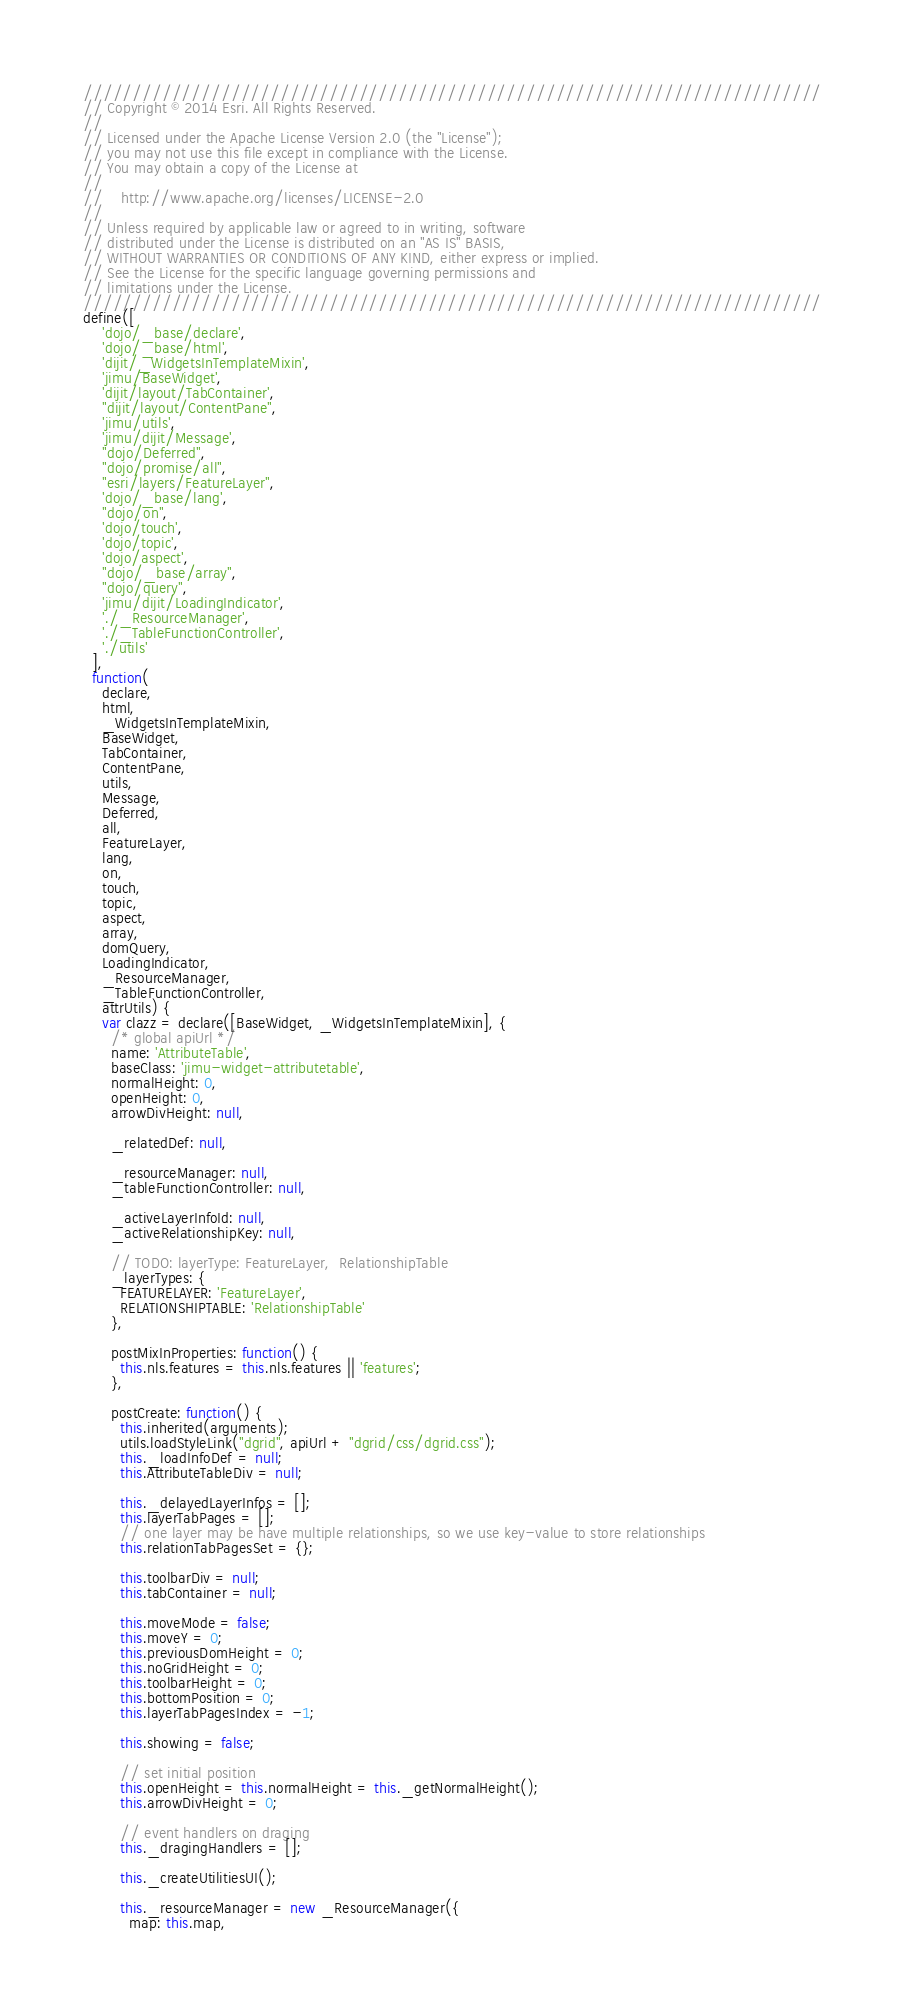<code> <loc_0><loc_0><loc_500><loc_500><_JavaScript_>///////////////////////////////////////////////////////////////////////////
// Copyright © 2014 Esri. All Rights Reserved.
//
// Licensed under the Apache License Version 2.0 (the "License");
// you may not use this file except in compliance with the License.
// You may obtain a copy of the License at
//
//    http://www.apache.org/licenses/LICENSE-2.0
//
// Unless required by applicable law or agreed to in writing, software
// distributed under the License is distributed on an "AS IS" BASIS,
// WITHOUT WARRANTIES OR CONDITIONS OF ANY KIND, either express or implied.
// See the License for the specific language governing permissions and
// limitations under the License.
///////////////////////////////////////////////////////////////////////////
define([
    'dojo/_base/declare',
    'dojo/_base/html',
    'dijit/_WidgetsInTemplateMixin',
    'jimu/BaseWidget',
    'dijit/layout/TabContainer',
    "dijit/layout/ContentPane",
    'jimu/utils',
    'jimu/dijit/Message',
    "dojo/Deferred",
    "dojo/promise/all",
    "esri/layers/FeatureLayer",
    'dojo/_base/lang',
    "dojo/on",
    'dojo/touch',
    'dojo/topic',
    'dojo/aspect',
    "dojo/_base/array",
    "dojo/query",
    'jimu/dijit/LoadingIndicator',
    './_ResourceManager',
    './_TableFunctionController',
    './utils'
  ],
  function(
    declare,
    html,
    _WidgetsInTemplateMixin,
    BaseWidget,
    TabContainer,
    ContentPane,
    utils,
    Message,
    Deferred,
    all,
    FeatureLayer,
    lang,
    on,
    touch,
    topic,
    aspect,
    array,
    domQuery,
    LoadingIndicator,
    _ResourceManager,
    _TableFunctionController,
    attrUtils) {
    var clazz = declare([BaseWidget, _WidgetsInTemplateMixin], {
      /* global apiUrl */
      name: 'AttributeTable',
      baseClass: 'jimu-widget-attributetable',
      normalHeight: 0,
      openHeight: 0,
      arrowDivHeight: null,

      _relatedDef: null,

      _resourceManager: null,
      _tableFunctionController: null,

      _activeLayerInfoId: null,
      _activeRelationshipKey: null,

      // TODO: layerType: FeatureLayer,  RelationshipTable
      _layerTypes: {
        FEATURELAYER: 'FeatureLayer',
        RELATIONSHIPTABLE: 'RelationshipTable'
      },

      postMixInProperties: function() {
        this.nls.features = this.nls.features || 'features';
      },

      postCreate: function() {
        this.inherited(arguments);
        utils.loadStyleLink("dgrid", apiUrl + "dgrid/css/dgrid.css");
        this._loadInfoDef = null;
        this.AttributeTableDiv = null;

        this._delayedLayerInfos = [];
        this.layerTabPages = [];
        // one layer may be have multiple relationships, so we use key-value to store relationships
        this.relationTabPagesSet = {};

        this.toolbarDiv = null;
        this.tabContainer = null;

        this.moveMode = false;
        this.moveY = 0;
        this.previousDomHeight = 0;
        this.noGridHeight = 0;
        this.toolbarHeight = 0;
        this.bottomPosition = 0;
        this.layerTabPagesIndex = -1;

        this.showing = false;

        // set initial position
        this.openHeight = this.normalHeight = this._getNormalHeight();
        this.arrowDivHeight = 0;

        // event handlers on draging
        this._dragingHandlers = [];

        this._createUtilitiesUI();

        this._resourceManager = new _ResourceManager({
          map: this.map,</code> 